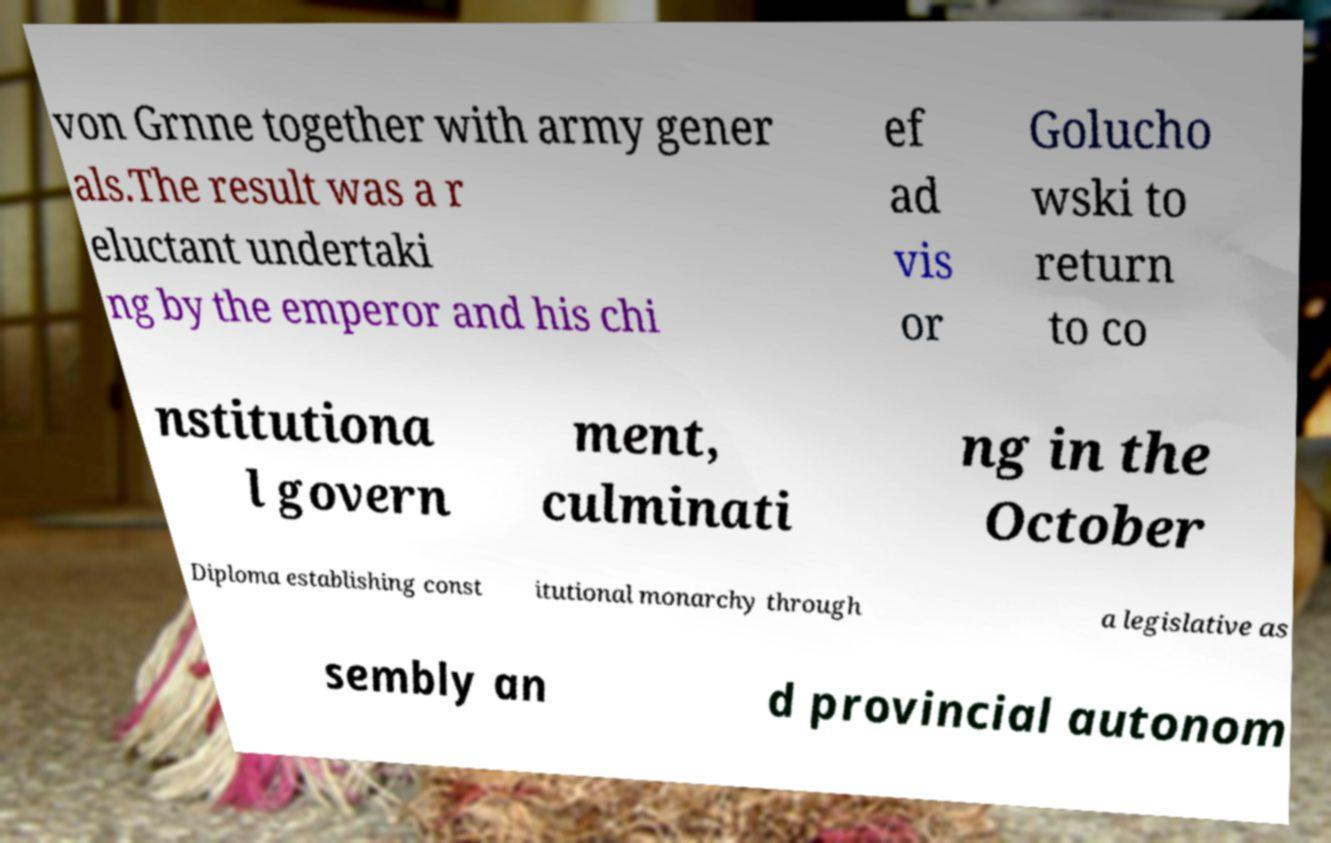Please read and relay the text visible in this image. What does it say? von Grnne together with army gener als.The result was a r eluctant undertaki ng by the emperor and his chi ef ad vis or Golucho wski to return to co nstitutiona l govern ment, culminati ng in the October Diploma establishing const itutional monarchy through a legislative as sembly an d provincial autonom 